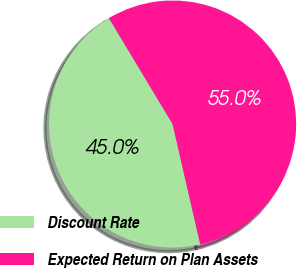Convert chart. <chart><loc_0><loc_0><loc_500><loc_500><pie_chart><fcel>Discount Rate<fcel>Expected Return on Plan Assets<nl><fcel>44.98%<fcel>55.02%<nl></chart> 